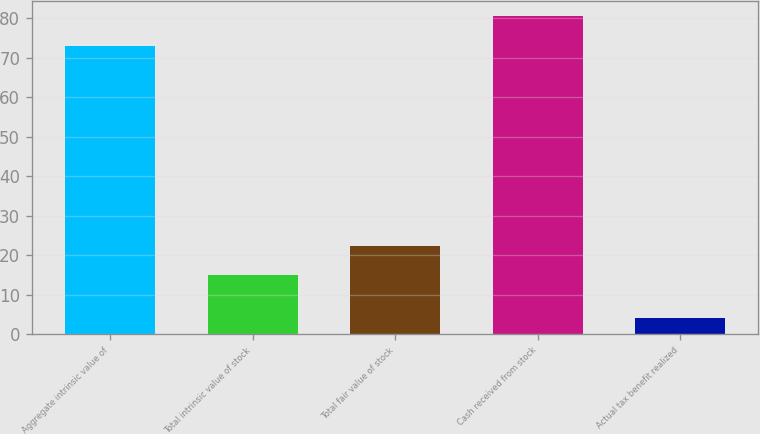Convert chart. <chart><loc_0><loc_0><loc_500><loc_500><bar_chart><fcel>Aggregate intrinsic value of<fcel>Total intrinsic value of stock<fcel>Total fair value of stock<fcel>Cash received from stock<fcel>Actual tax benefit realized<nl><fcel>73<fcel>15<fcel>22.4<fcel>80.4<fcel>4<nl></chart> 